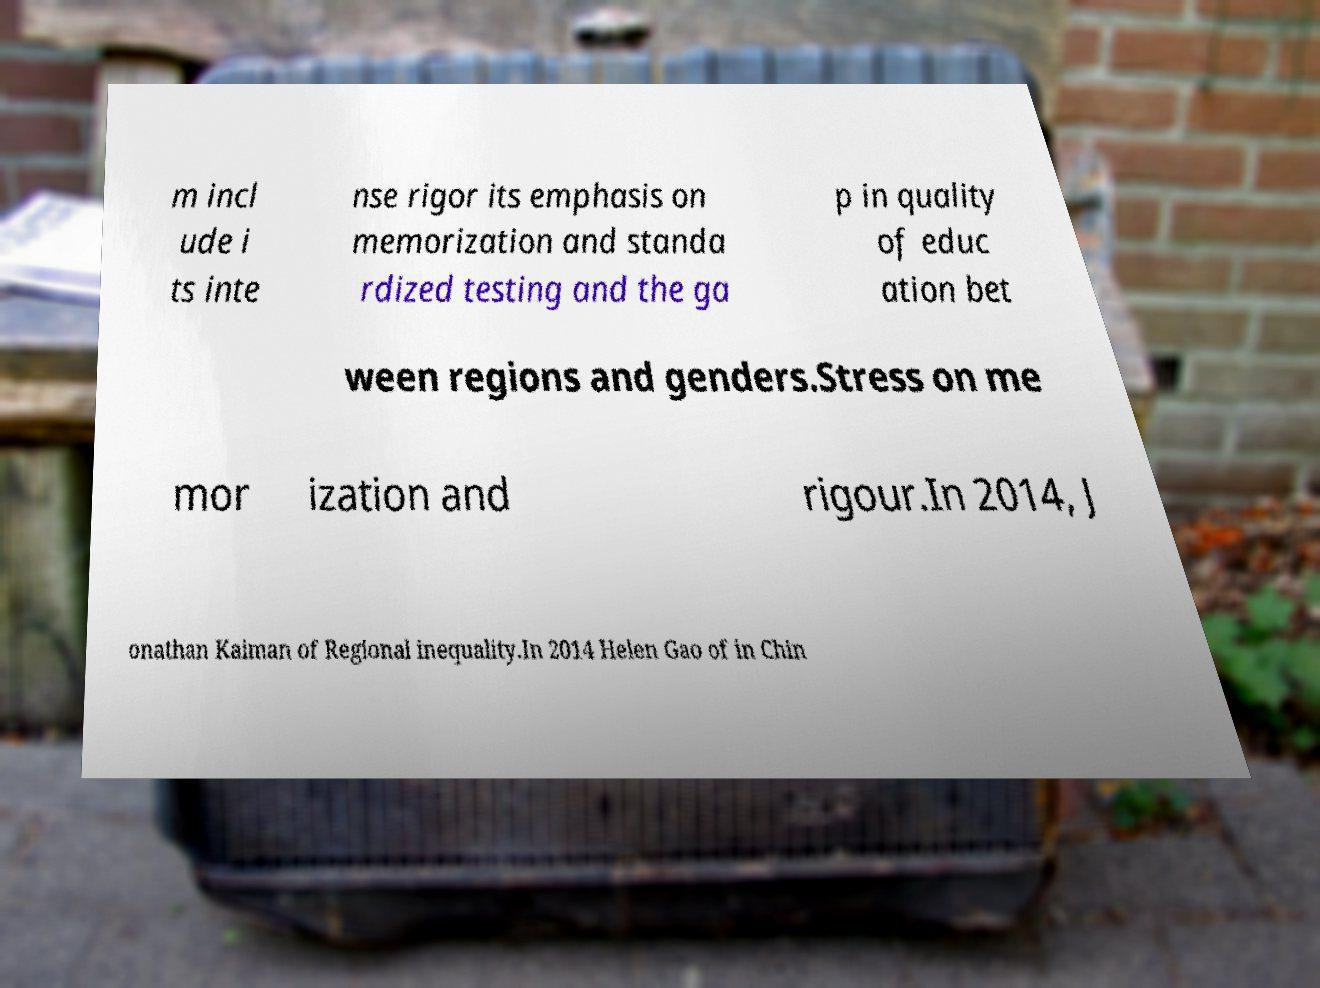Could you extract and type out the text from this image? m incl ude i ts inte nse rigor its emphasis on memorization and standa rdized testing and the ga p in quality of educ ation bet ween regions and genders.Stress on me mor ization and rigour.In 2014, J onathan Kaiman of Regional inequality.In 2014 Helen Gao of in Chin 